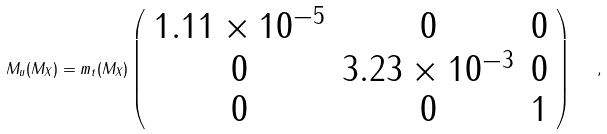<formula> <loc_0><loc_0><loc_500><loc_500>M _ { u } ( M _ { X } ) = m _ { t } ( M _ { X } ) \left ( \begin{array} { c c c } 1 . 1 1 \times 1 0 ^ { - 5 } & 0 & 0 \\ 0 & 3 . 2 3 \times 1 0 ^ { - 3 } & 0 \\ 0 & 0 & 1 \\ \end{array} \right ) \ \ ,</formula> 